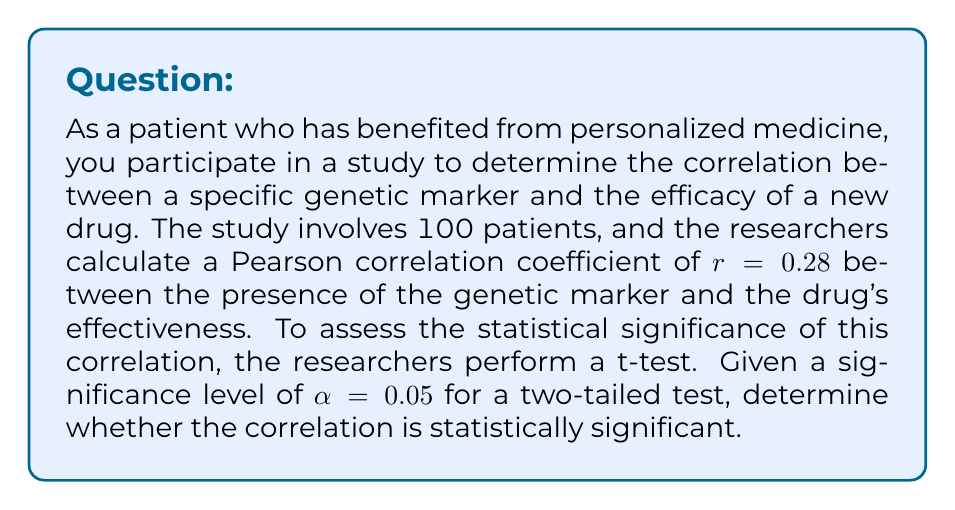Show me your answer to this math problem. To determine the statistical significance of the correlation, we'll follow these steps:

1. Calculate the t-statistic:
   The formula for the t-statistic in this case is:
   $$ t = r \sqrt{\frac{n-2}{1-r^2}} $$
   where r is the correlation coefficient and n is the sample size.

2. Determine the degrees of freedom:
   $$ df = n - 2 $$

3. Find the critical t-value for a two-tailed test with α = 0.05 and the calculated degrees of freedom.

4. Compare the calculated t-statistic with the critical t-value.

Step 1: Calculate the t-statistic
$$ t = 0.28 \sqrt{\frac{100-2}{1-0.28^2}} = 0.28 \sqrt{\frac{98}{0.9216}} = 0.28 \sqrt{106.3369} = 0.28 * 10.3120 = 2.8874 $$

Step 2: Determine the degrees of freedom
$$ df = 100 - 2 = 98 $$

Step 3: Find the critical t-value
For a two-tailed test with α = 0.05 and df = 98, the critical t-value is approximately 1.9845 (from a t-distribution table or calculator).

Step 4: Compare the t-statistic with the critical t-value
The calculated t-statistic (2.8874) is greater than the critical t-value (1.9845).

Therefore, we reject the null hypothesis that there is no correlation between the genetic marker and drug efficacy. The correlation is statistically significant at the 0.05 level.
Answer: The correlation between the genetic marker and drug efficacy is statistically significant (t(98) = 2.8874, p < 0.05). 